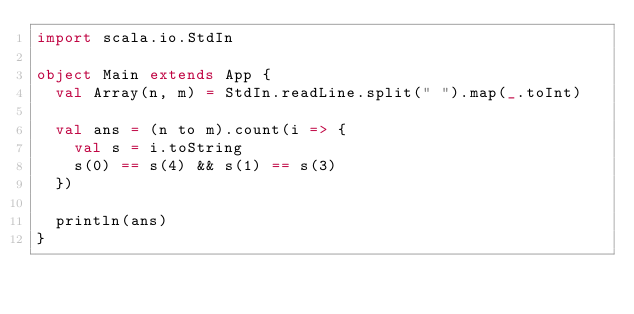Convert code to text. <code><loc_0><loc_0><loc_500><loc_500><_Scala_>import scala.io.StdIn

object Main extends App {
  val Array(n, m) = StdIn.readLine.split(" ").map(_.toInt)

  val ans = (n to m).count(i => {
    val s = i.toString
    s(0) == s(4) && s(1) == s(3)
  })

  println(ans)
}
</code> 